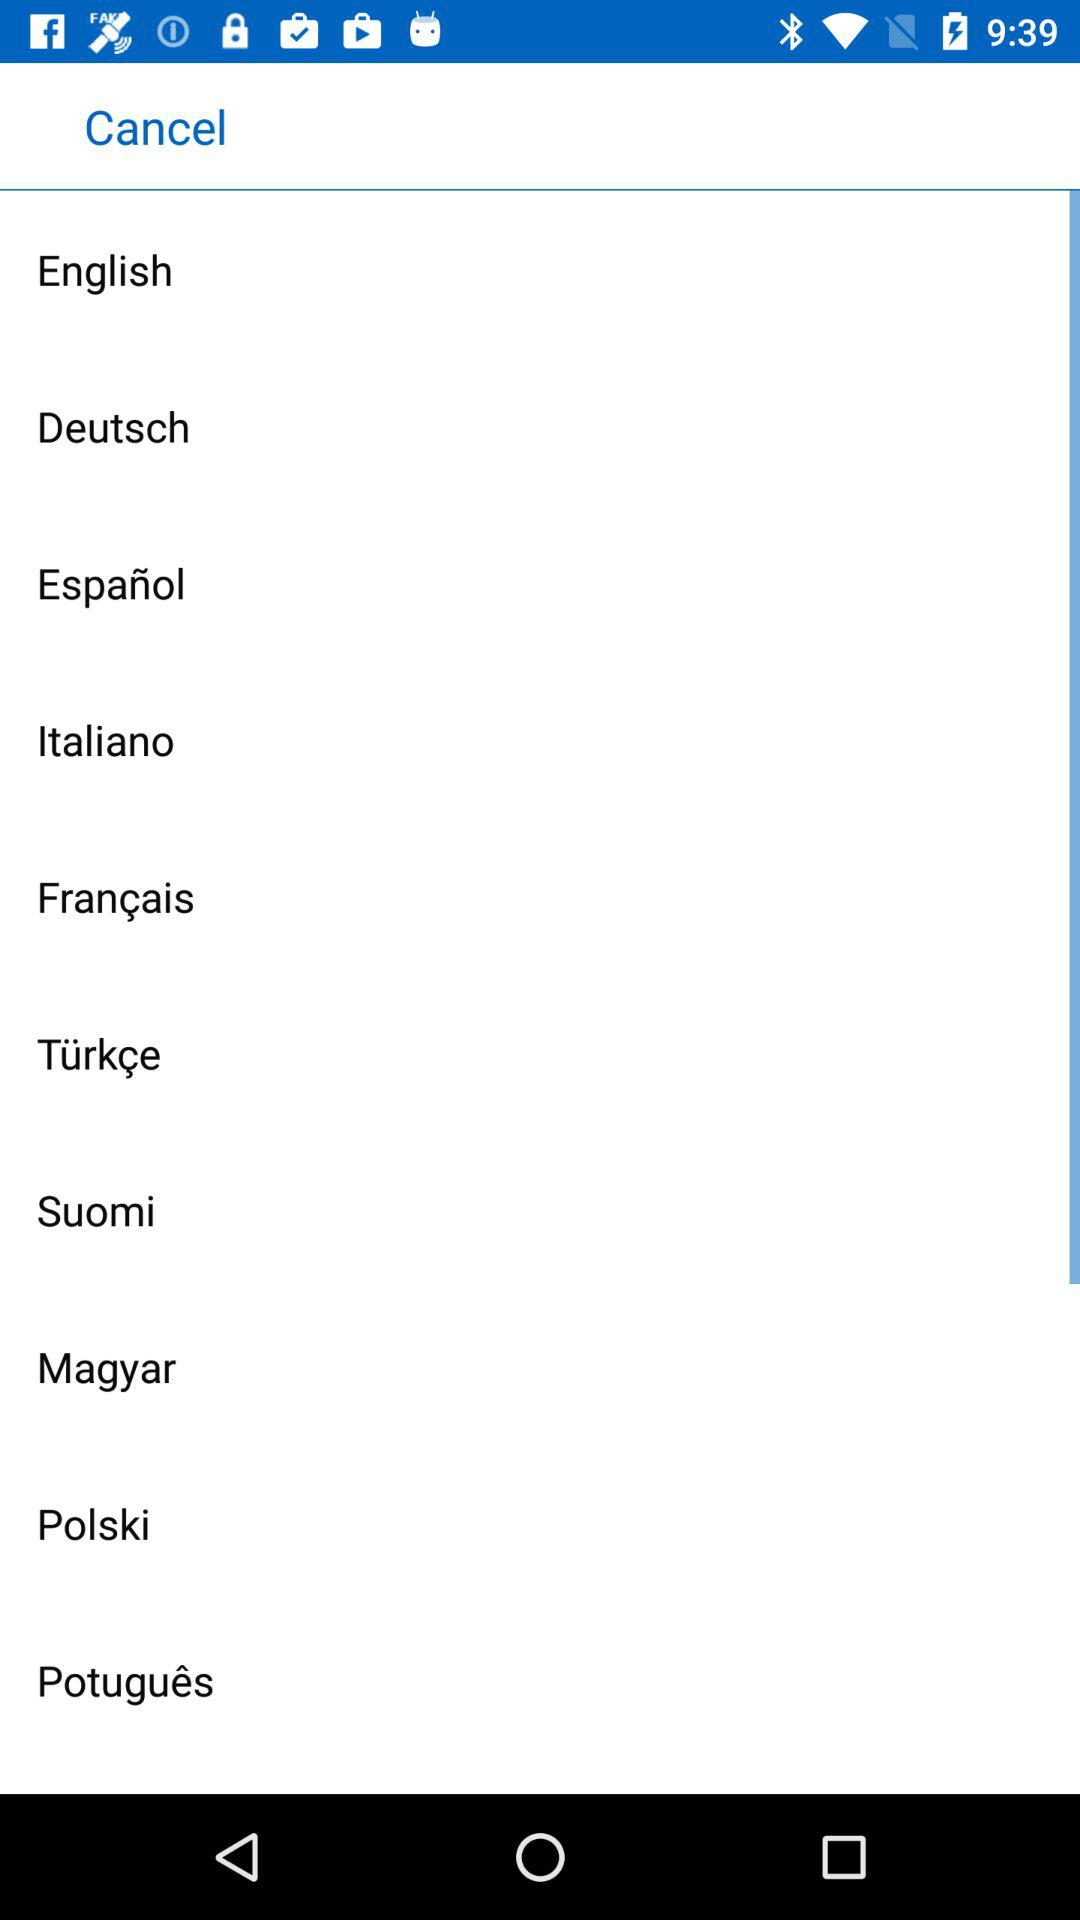How many languages are available to choose from?
Answer the question using a single word or phrase. 10 